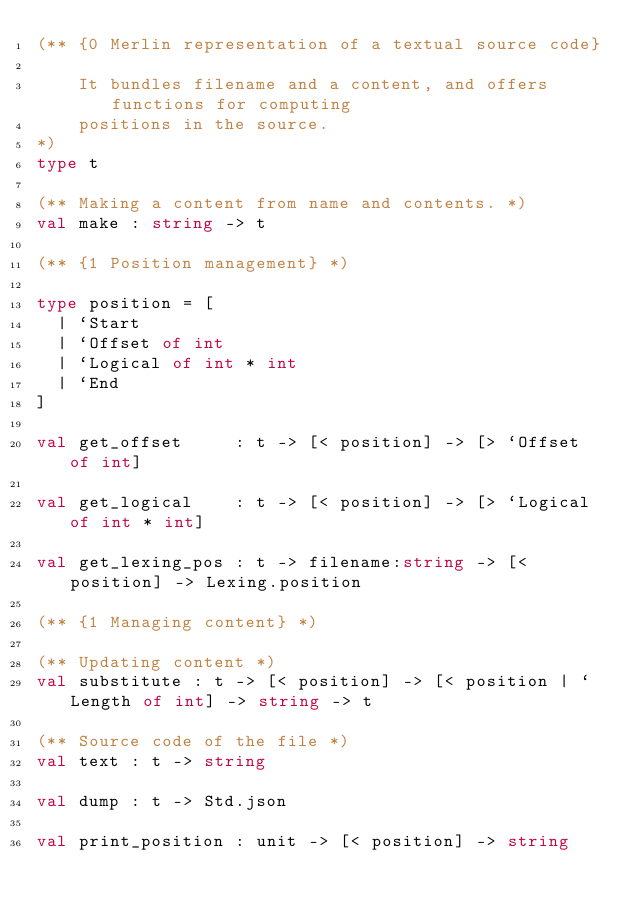<code> <loc_0><loc_0><loc_500><loc_500><_OCaml_>(** {0 Merlin representation of a textual source code}

    It bundles filename and a content, and offers functions for computing
    positions in the source.
*)
type t

(** Making a content from name and contents. *)
val make : string -> t

(** {1 Position management} *)

type position = [
  | `Start
  | `Offset of int
  | `Logical of int * int
  | `End
]

val get_offset     : t -> [< position] -> [> `Offset of int]

val get_logical    : t -> [< position] -> [> `Logical of int * int]

val get_lexing_pos : t -> filename:string -> [< position] -> Lexing.position

(** {1 Managing content} *)

(** Updating content *)
val substitute : t -> [< position] -> [< position | `Length of int] -> string -> t

(** Source code of the file *)
val text : t -> string

val dump : t -> Std.json

val print_position : unit -> [< position] -> string
</code> 